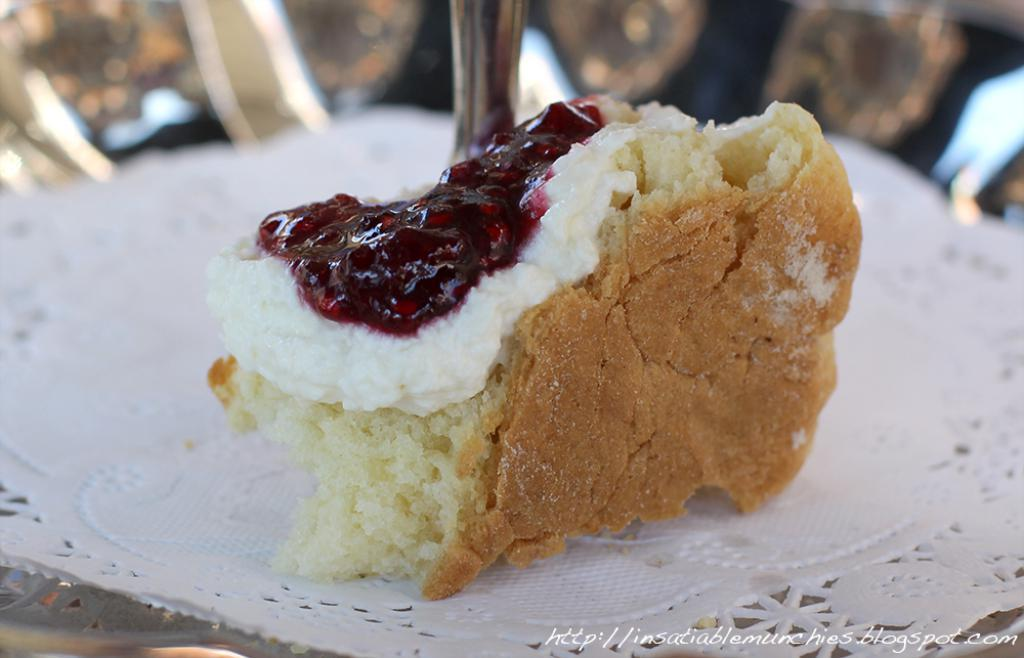What type of dessert is visible in the image? There is a piece of cake in the image. What is on top of the cake? The cake has cream and jam on it. On what is the cake placed? The cake is present on a plate. What type of spot can be seen on the cake in the image? There is no spot visible on the cake in the image. What type of iron is used to make the cake in the image? There is no iron present in the image, as cakes are typically baked in an oven. 